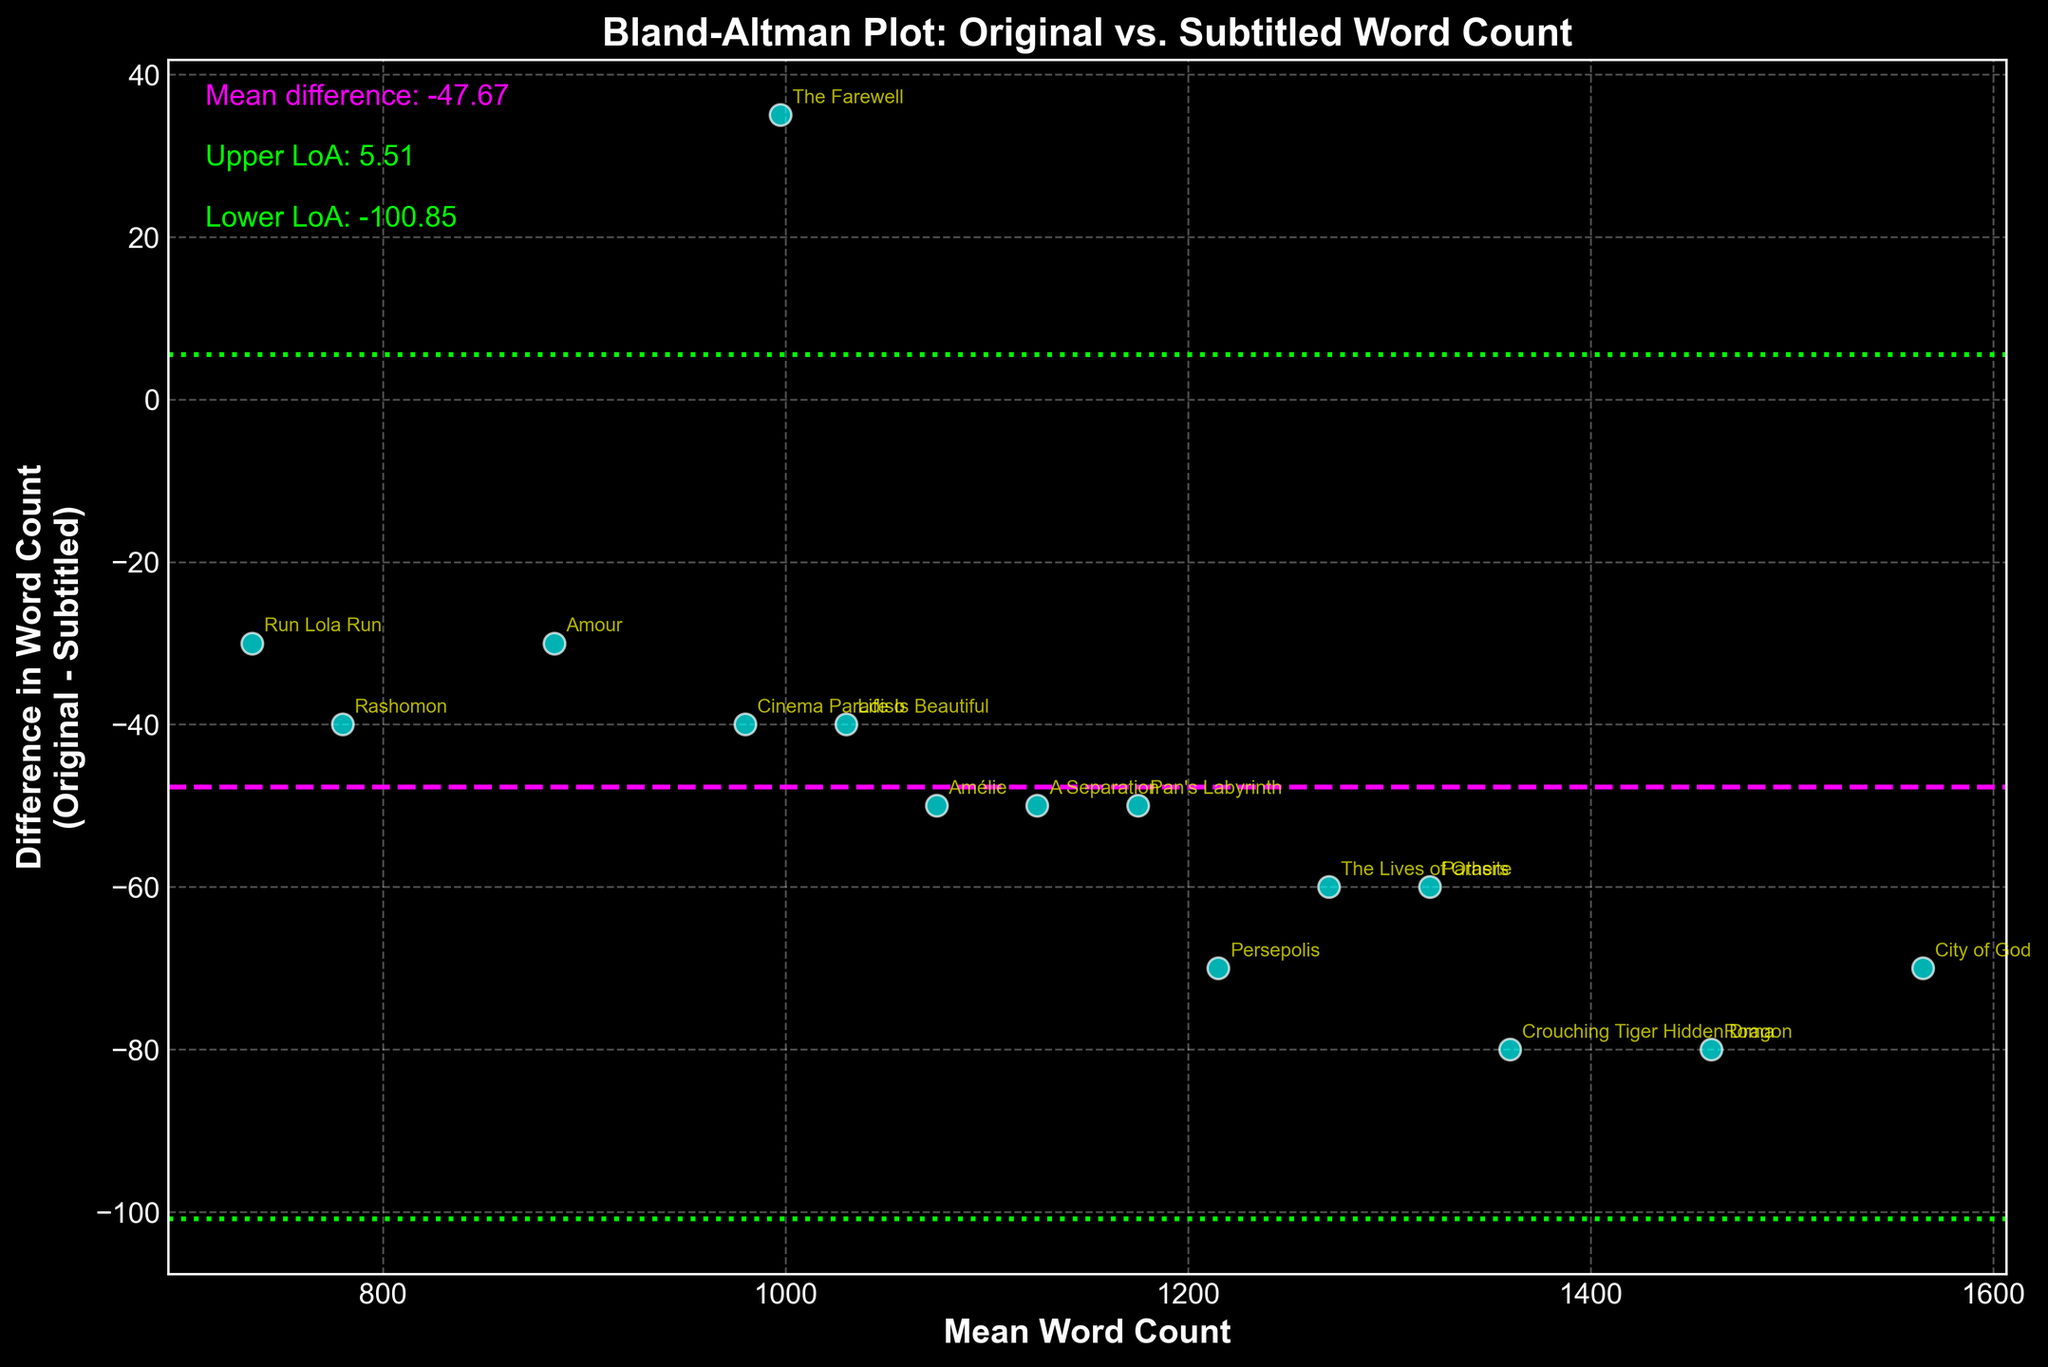What is the title of the plot? The title is usually found at the top of the plot. Here, it reads "Bland-Altman Plot: Original vs. Subtitled Word Count."
Answer: Bland-Altman Plot: Original vs. Subtitled Word Count What are the labels of the x-axis and y-axis? The x-axis label reads "Mean Word Count," and the y-axis label reads "Difference in Word Count (Original - Subtitled)."
Answer: Mean Word Count; Difference in Word Count (Original - Subtitled) What color represents the data points in the plot? The data points are represented in cyan according to their appearance in the plot.
Answer: Cyan How many data points are plotted? By counting the number of data points (or film titles) annotated, there are 15.
Answer: 15 Where is the mean difference line located? The mean difference line is shown as a magenta dashed line, representing the average of the differences.
Answer: At the value of the mean difference (-55.33) What is the range of the y-axis? The y-axis ranges from (approximately) -100 to 50, encapsulating all the differences in word count.
Answer: -100 to 50 What is the upper limit of agreement (LoA) value? The upper limit of agreement is marked by a lime dotted line above the mean difference. It is 11.71.
Answer: 11.71 Which film has the highest positive difference in word count? The data point that appears highest above the zero line on the y-axis corresponds to "The Farewell" with a positive difference of 35.
Answer: The Farewell Which film has the lowest mean word count? The plot's x-axis highlights "Run Lola Run," positioned furthest to the left with a mean word count of 735.
Answer: Run Lola Run For which film is the difference in word count closest to zero? The data point closest to the y-axis zero line belongs to "Amour" with a difference of -30.
Answer: Amour 